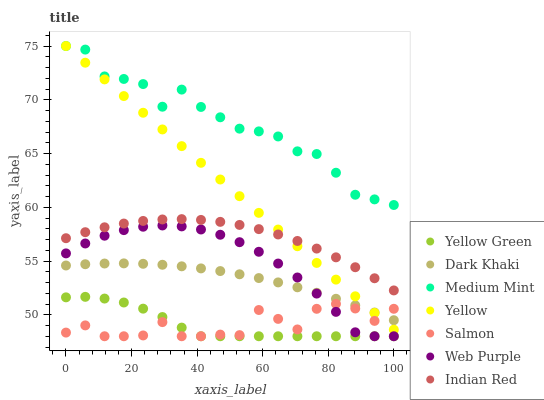Does Yellow Green have the minimum area under the curve?
Answer yes or no. Yes. Does Medium Mint have the maximum area under the curve?
Answer yes or no. Yes. Does Salmon have the minimum area under the curve?
Answer yes or no. No. Does Salmon have the maximum area under the curve?
Answer yes or no. No. Is Yellow the smoothest?
Answer yes or no. Yes. Is Salmon the roughest?
Answer yes or no. Yes. Is Yellow Green the smoothest?
Answer yes or no. No. Is Yellow Green the roughest?
Answer yes or no. No. Does Yellow Green have the lowest value?
Answer yes or no. Yes. Does Yellow have the lowest value?
Answer yes or no. No. Does Yellow have the highest value?
Answer yes or no. Yes. Does Yellow Green have the highest value?
Answer yes or no. No. Is Dark Khaki less than Medium Mint?
Answer yes or no. Yes. Is Medium Mint greater than Dark Khaki?
Answer yes or no. Yes. Does Salmon intersect Web Purple?
Answer yes or no. Yes. Is Salmon less than Web Purple?
Answer yes or no. No. Is Salmon greater than Web Purple?
Answer yes or no. No. Does Dark Khaki intersect Medium Mint?
Answer yes or no. No. 